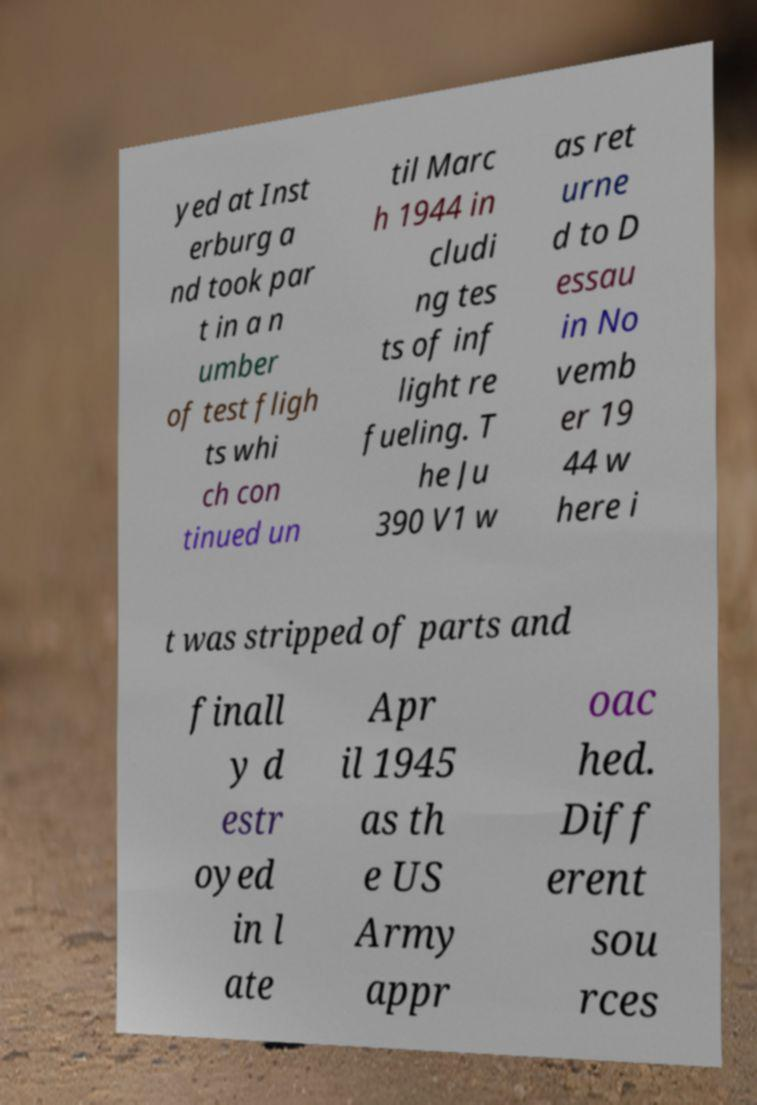Could you extract and type out the text from this image? yed at Inst erburg a nd took par t in a n umber of test fligh ts whi ch con tinued un til Marc h 1944 in cludi ng tes ts of inf light re fueling. T he Ju 390 V1 w as ret urne d to D essau in No vemb er 19 44 w here i t was stripped of parts and finall y d estr oyed in l ate Apr il 1945 as th e US Army appr oac hed. Diff erent sou rces 